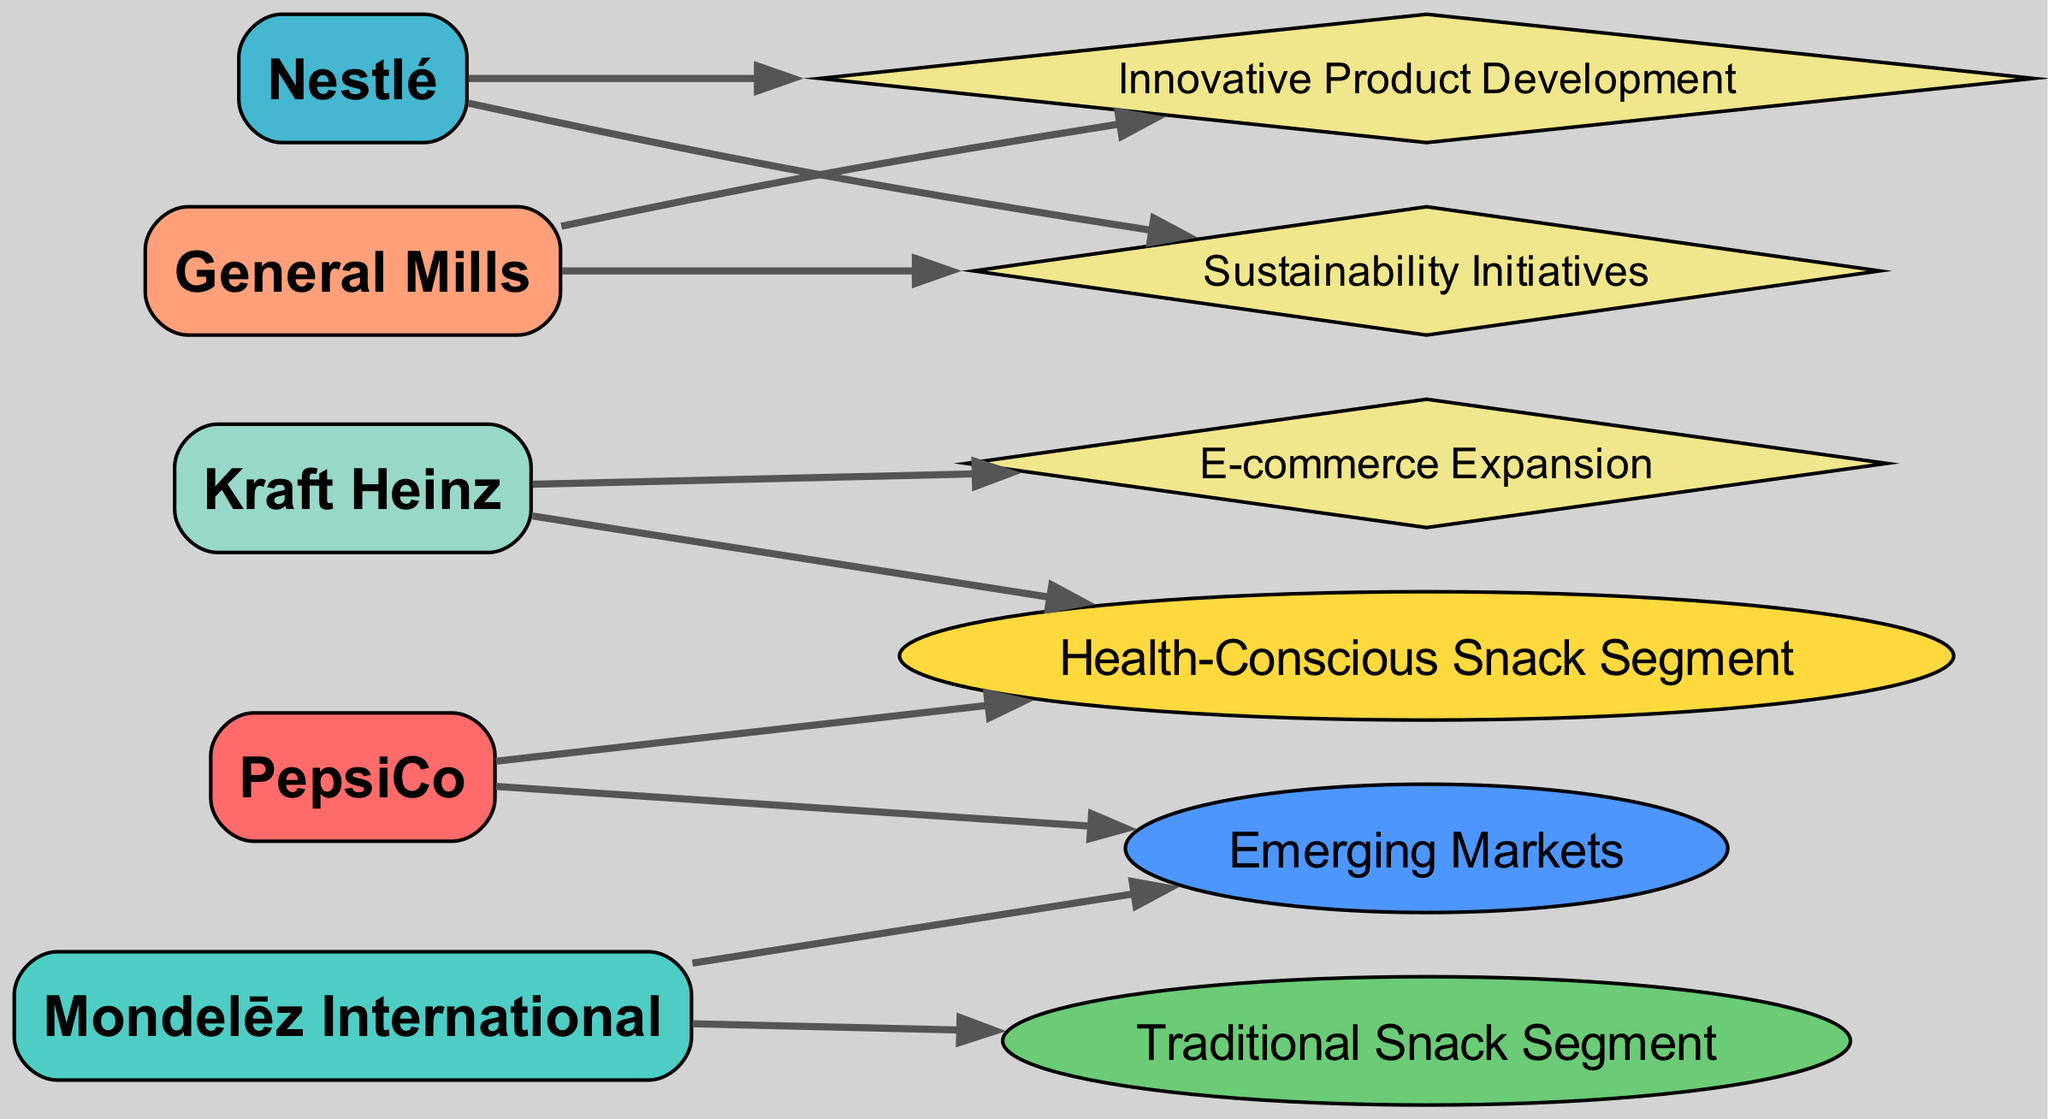What is the total number of nodes in the diagram? The diagram contains five company nodes (PepsiCo, Mondelēz International, Nestlé, General Mills, Kraft Heinz) and six additional nodes (health-conscious snack segment, traditional snack segment, emerging markets, innovative product development, sustainability initiatives, e-commerce expansion), which sums up to a total of 11 nodes.
Answer: 11 Which company is connected to the health-conscious snack segment? The edge from PepsiCo to the health-conscious snack segment indicates that PepsiCo is directly associated with this segment, as per the directed graph structure.
Answer: PepsiCo How many companies target emerging markets? Both PepsiCo and Mondelēz International have edges pointing towards the emerging markets node, indicating they are both focused on this area. Thus, there are two companies targeting emerging markets.
Answer: 2 What type of strategy is Kraft Heinz focusing on? The edge from Kraft Heinz to the e-commerce expansion node identifies that Kraft Heinz is implementing a strategy regarding e-commerce growth, as this node represents a strategic focus area.
Answer: E-commerce Expansion Which segment is associated with General Mills? The directed edge from General Mills leads to the innovative product development node, indicating that this is the segment they are connected to in the graph.
Answer: Innovative Product Development What common strategy do both PepsiCo and Nestlé share? Both companies have connections to the emerging markets node, demonstrating that they are both focusing on strategies aimed at increasing their presence in these regions.
Answer: Emerging Markets Which company is related to sustainability initiatives? The directed edge from Nestlé to the sustainability initiatives node reveals that this company is actively engaged in implementing sustainability-focused strategies.
Answer: Nestlé How many edges are present in the diagram? Counting all the directed relationships displayed in the diagram, there are a total of 10 edges connecting the various nodes, representing company strategies and market segments.
Answer: 10 Which two companies are connected to the health-conscious snack segment? The edges leading into the health-conscious snack segment show that both PepsiCo and Kraft Heinz are actively connected to this segment, suggesting a focus on health-oriented products.
Answer: PepsiCo, Kraft Heinz 